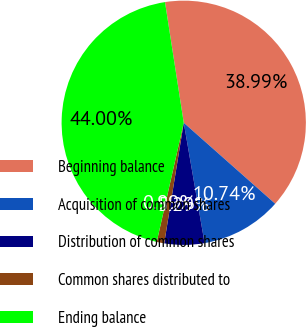Convert chart. <chart><loc_0><loc_0><loc_500><loc_500><pie_chart><fcel>Beginning balance<fcel>Acquisition of common shares<fcel>Distribution of common shares<fcel>Common shares distributed to<fcel>Ending balance<nl><fcel>38.99%<fcel>10.74%<fcel>5.29%<fcel>0.99%<fcel>44.0%<nl></chart> 